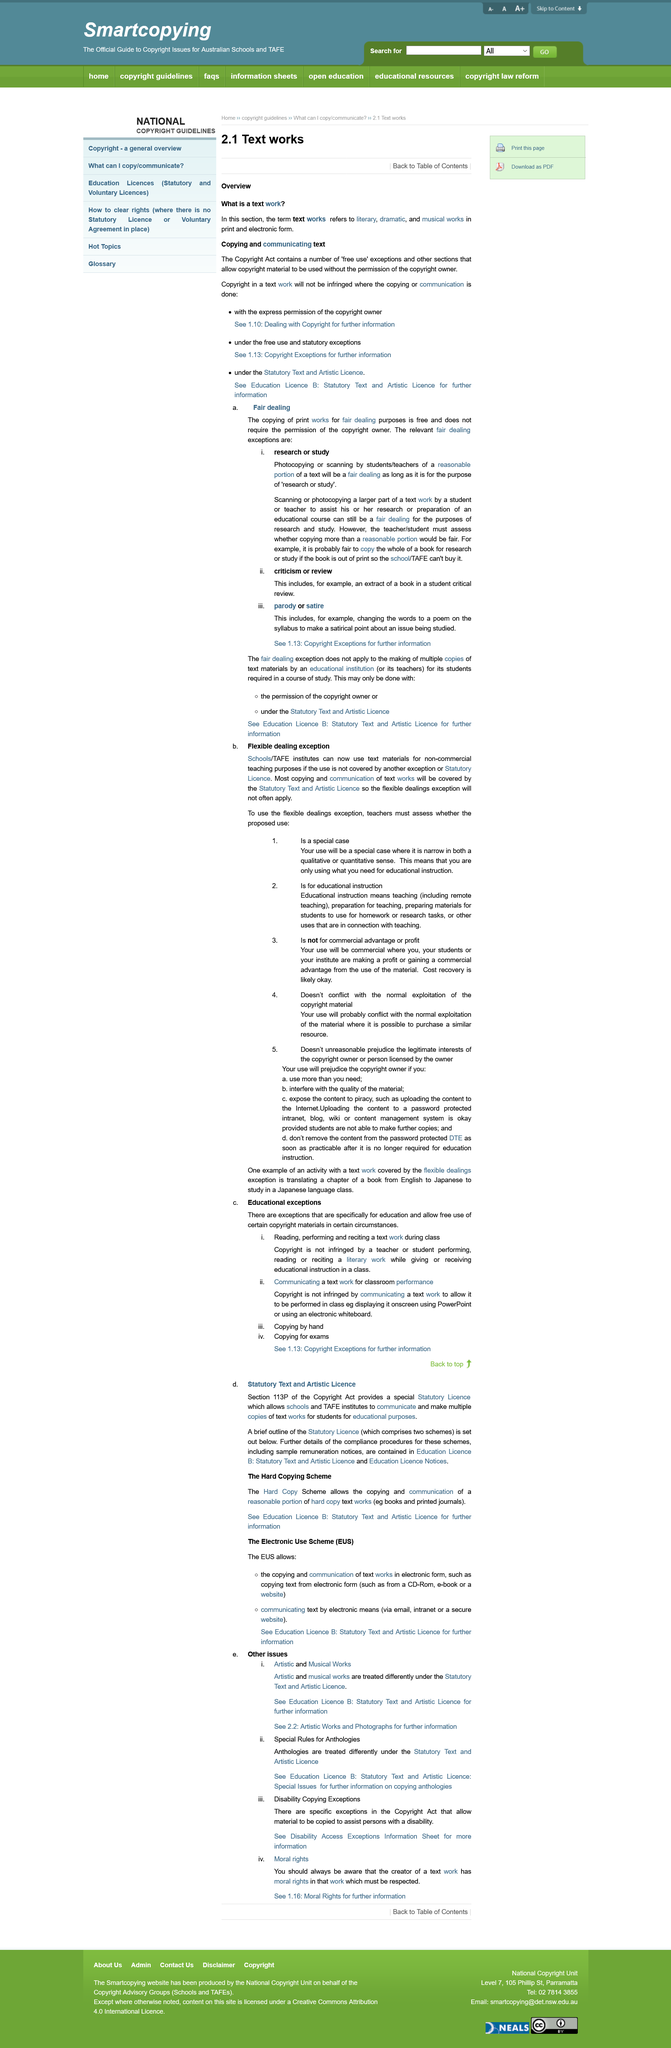Draw attention to some important aspects in this diagram. The three relevant fair dealing exceptions listed in the image are: research or study, criticism or review, and parody or satire. The requirements to use the flexible dealing exception are that the proposed use must be a special case, such as for educational instruction, and not for commercial advantage or profit. The copying of print works for fair dealing purposes is free and not subject to copyright infringement. The copyright act is explicitly mentioned in the text. The page is seeking to answer the question, "What is text work". 